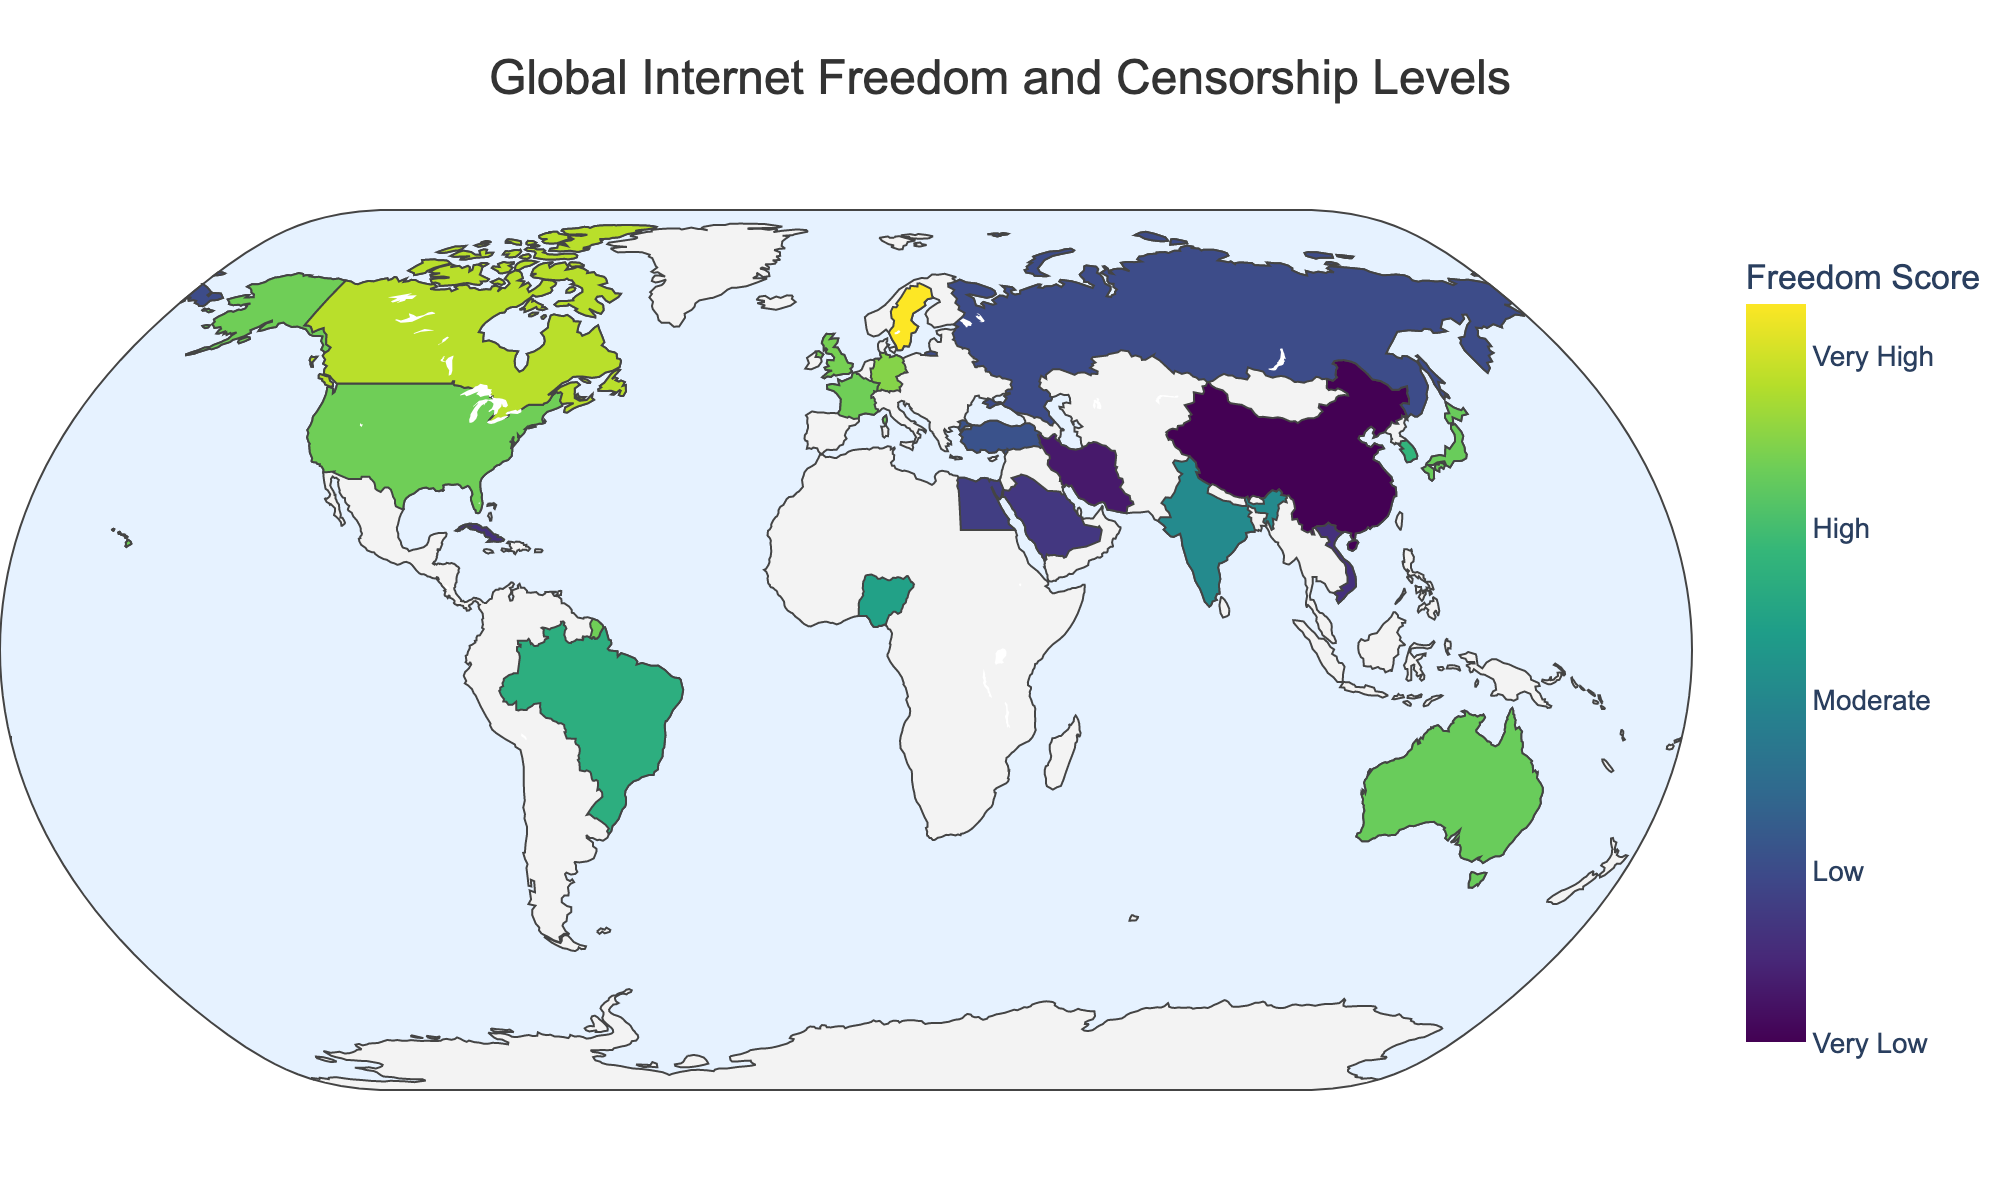How is the Internet Freedom Score represented visually? The Internet Freedom Score is represented by a color scale, with different shades corresponding to different levels of freedom. The score's color ranges from dark in low scores to light in high scores, as indicated by the color bar on the side of the map.
Answer: By color Which country has the highest Internet Freedom Score? According to the plot, Sweden has the highest Internet Freedom Score with a score of 96.
Answer: Sweden Compare the Internet Freedom Scores between China and India. China has an Internet Freedom Score of 10, whereas India has a score of 51. Therefore, India's score is significantly higher than China's.
Answer: India has a higher score How many countries are listed with a "High" Censorship Level, and which are they? The map data indicates that there are five countries with a "High" Censorship Level: Russia, Turkey, Saudi Arabia, Egypt, and Cuba.
Answer: 5; Russia, Turkey, Saudi Arabia, Egypt, Cuba Is there any country with a "Very Low" Censorship Level? If so, name it. Yes, Sweden is the only country with a "Very Low" Censorship Level based on the provided data.
Answer: Sweden Compare the Internet Freedom Scores of Germany and Japan. Which country has a lower score? Germany has an Internet Freedom Score of 80, while Japan has a score of 76. Thus, Japan has a slightly lower score than Germany.
Answer: Japan What is the range of Internet Freedom Scores depicted on the figure? The scores range from the lowest value of 10 (China) to the highest value of 96 (Sweden).
Answer: 10 to 96 Which countries have a "Moderate" Censorship Level, and what are their Internet Freedom Scores? The countries with a "Moderate" Censorship Level are South Korea (66), India (51), Brazil (64), and Nigeria (59).
Answer: South Korea (66), India (51), Brazil (64), Nigeria (59) How does the Internet Freedom Score of the United States compare with that of the United Kingdom? The United States has an Internet Freedom Score of 77, whereas the United Kingdom has a score of 78. Therefore, the United Kingdom has a slightly higher score than the United States.
Answer: United Kingdom has a higher score What can you infer about the correlation between Internet Freedom Scores and Censorship Levels on this map? Generally, countries with higher Internet Freedom Scores tend to have lower Censorship Levels (e.g., Sweden), while countries with lower Internet Freedom Scores tend to have higher or very high Censorship Levels (e.g., China, Iran).
Answer: Higher scores correlate with lower censorship levels 